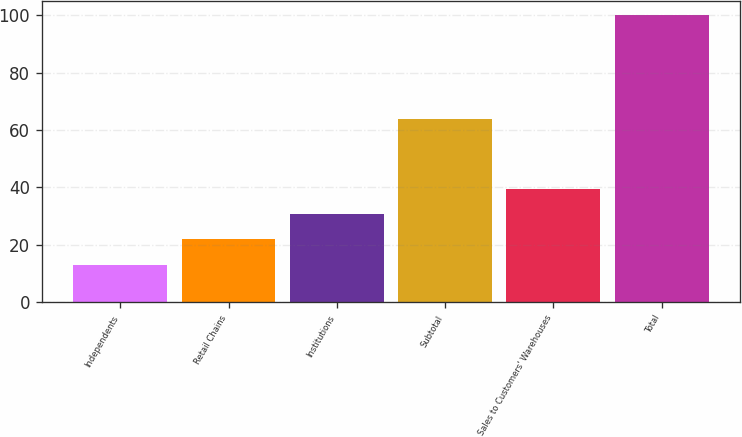<chart> <loc_0><loc_0><loc_500><loc_500><bar_chart><fcel>Independents<fcel>Retail Chains<fcel>Institutions<fcel>Subtotal<fcel>Sales to Customers' Warehouses<fcel>Total<nl><fcel>13<fcel>22<fcel>30.7<fcel>64<fcel>39.4<fcel>100<nl></chart> 